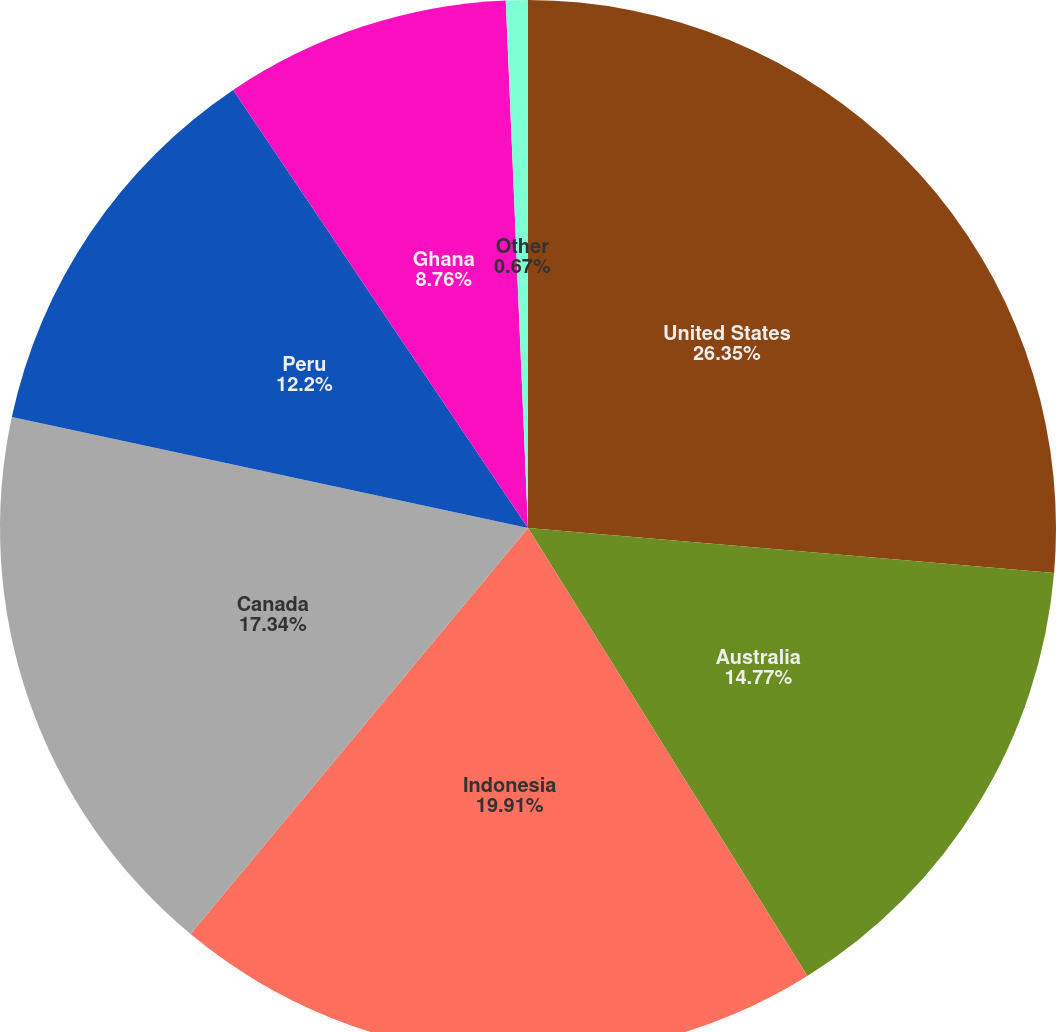<chart> <loc_0><loc_0><loc_500><loc_500><pie_chart><fcel>United States<fcel>Australia<fcel>Indonesia<fcel>Canada<fcel>Peru<fcel>Ghana<fcel>Other<nl><fcel>26.36%<fcel>14.77%<fcel>19.91%<fcel>17.34%<fcel>12.2%<fcel>8.76%<fcel>0.67%<nl></chart> 